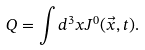Convert formula to latex. <formula><loc_0><loc_0><loc_500><loc_500>Q = \int d ^ { 3 } x J ^ { 0 } ( \vec { x } , t ) .</formula> 